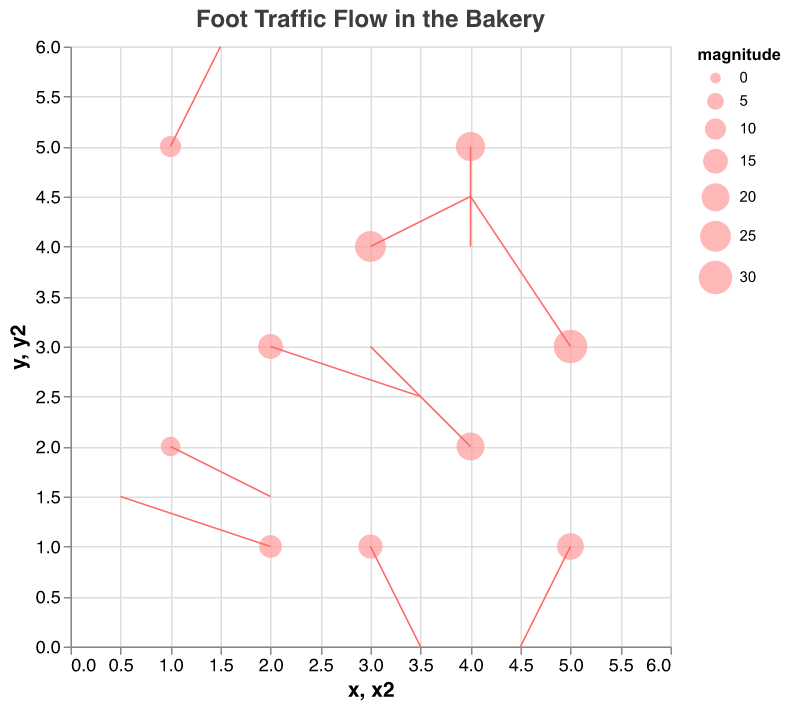What's the title of the figure? The title of the figure is displayed at the top and it says "Foot Traffic Flow in the Bakery".
Answer: Foot Traffic Flow in the Bakery How many data points are shown in the plot? Each point represents a unique coordinate pair with traffic flow vectors, and there are 10 such points.
Answer: 10 Which data point has the highest magnitude and where is it located? By looking at the size of the points, the largest point has the highest magnitude. This point is located at (5, 3).
Answer: (5, 3) What is the direction of the traffic flow at coordinate (4, 2)? At (4, 2), the traffic flow vector points in the direction of (-1, 1), which means it moves left and up.
Answer: left and up What color are the points and the flow arrows in the plot? The points are colored light pink, while the arrows are a darker pink.
Answer: light pink (points) and darker pink (arrows) Examine the position (2, 1). What is the approximate length and direction of the arrow? The arrow at (2, 1) points in the direction (-1.5, 0.5). To determine the length, calculate the vector's magnitude, which is approximately 1.58 (sqrt((-1.5)^2 + (0.5)^2)).
Answer: 1.58 units, left and slightly up Compare the data points at (3, 4) and (4, 5). Which one has a larger magnitude value, and what are the differences in their flow directions? The data point at (3, 4) has a magnitude of 25 and moves in the direction (1, 0.5). The data point at (4, 5) has a magnitude of 22 and moves in the direction (0, -1). Therefore, the point at (3, 4) has a larger magnitude and moves right and slightly up, whereas the point at (4, 5) moves directly down.
Answer: (3, 4) has a larger magnitude Which arrow shows the longest distance traveled from its origin point? The longest arrow corresponds to the largest vector, which is the one at coordinate (5, 3) with a vector magnitude direction (-1, 1.5). Calculating its length as sqrt((-1)^2 + (1.5)^2) = sqrt(1 + 2.25) = sqrt(3.25) ≈ 1.8. This is checked and compared with all other vectors, confirming it is the largest.
Answer: (5, 3) At the data point located at (1, 5), in which direction is the foot traffic heading, and what is the location of the vector's endpoint? The direction of traffic flow at (1, 5) is (0.5, 1). The endpoint is calculated as adding the vector to the point's coordinates: (1 + 0.5, 5 + 1) = (1.5, 6).
Answer: direction (0.5, 1), endpoint (1.5, 6) At what location does the arrow originating at (3, 1) point to, and what does it suggest about foot traffic behavior there? The arrow at (3, 1) points in the direction (0.5, -1). Adding this to its coordinates, we get the endpoint (3+0.5, 1-1) which is (3.5, 0). This suggests that foot traffic tends to move southeast from (3, 1) towards the lower right direction.
Answer: (3.5, 0) 